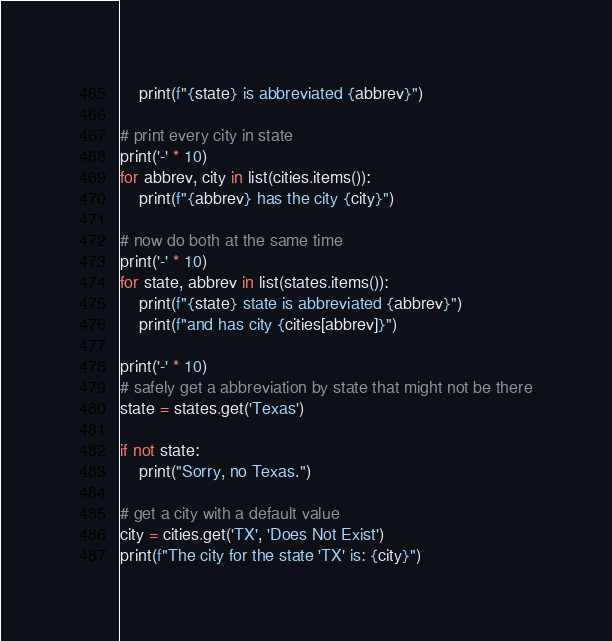<code> <loc_0><loc_0><loc_500><loc_500><_Python_>    print(f"{state} is abbreviated {abbrev}")

# print every city in state
print('-' * 10)
for abbrev, city in list(cities.items()):
    print(f"{abbrev} has the city {city}")

# now do both at the same time
print('-' * 10)
for state, abbrev in list(states.items()):
    print(f"{state} state is abbreviated {abbrev}")
    print(f"and has city {cities[abbrev]}")

print('-' * 10)
# safely get a abbreviation by state that might not be there
state = states.get('Texas')

if not state:
    print("Sorry, no Texas.")

# get a city with a default value
city = cities.get('TX', 'Does Not Exist')
print(f"The city for the state 'TX' is: {city}")

</code> 